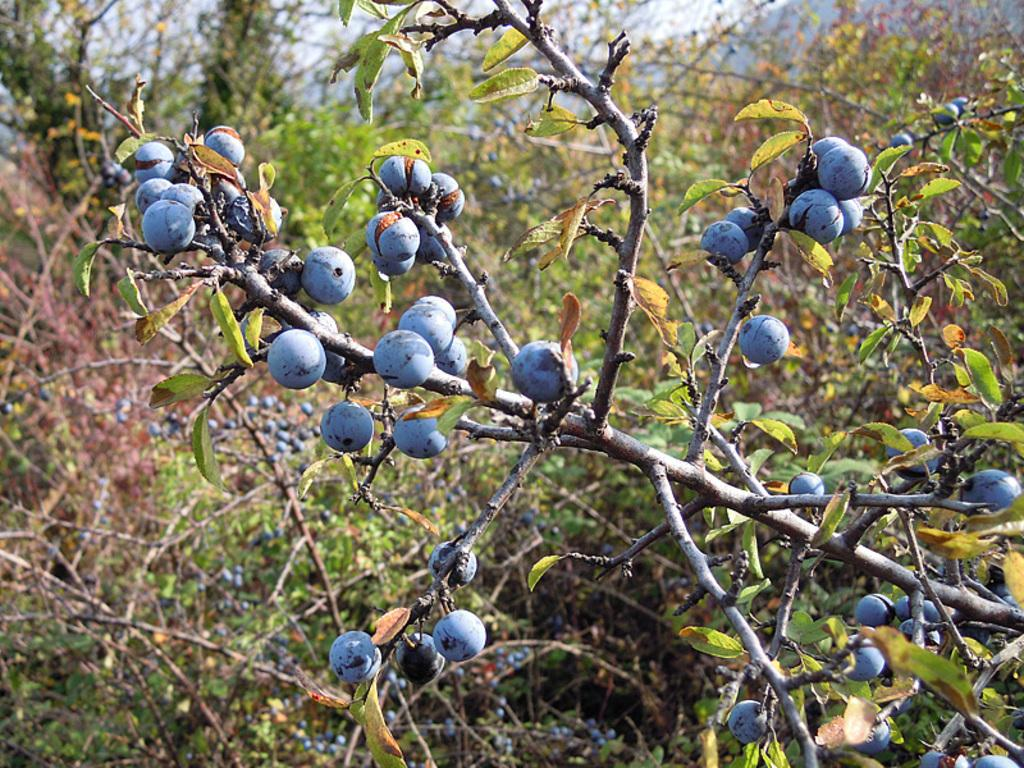What types of living organisms can be seen in the image? Plants can be seen in the image. What else can be found in the image besides plants? There are fruits in the image. How many pigs are visible in the image? There are no pigs present in the image. What type of hair can be seen on the plants in the image? The plants in the image do not have hair, as they are not animals. 